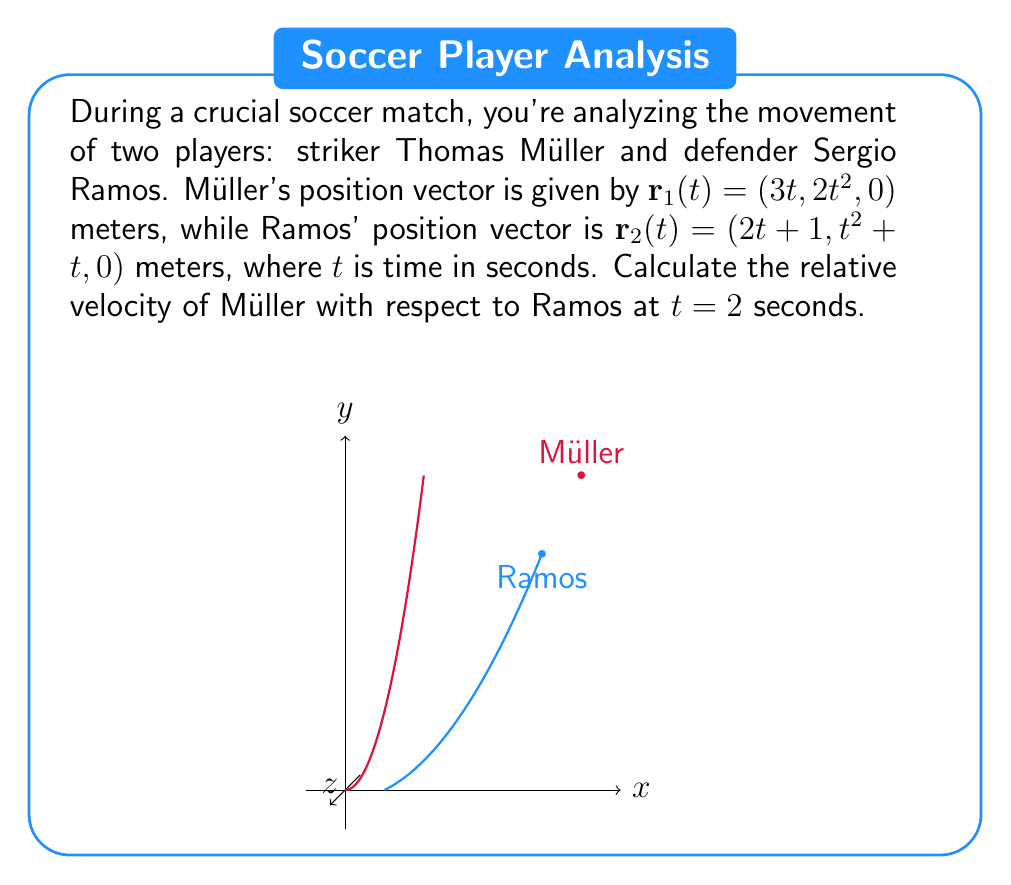Provide a solution to this math problem. To solve this problem, we'll follow these steps:

1) First, we need to find the velocity vectors for both players by differentiating their position vectors with respect to time:

   For Müller: $\mathbf{v}_1(t) = \frac{d}{dt}\mathbf{r}_1(t) = (3, 4t, 0)$
   For Ramos: $\mathbf{v}_2(t) = \frac{d}{dt}\mathbf{r}_2(t) = (2, 2t+1, 0)$

2) The relative velocity is the difference between these velocity vectors:

   $\mathbf{v}_{rel}(t) = \mathbf{v}_1(t) - \mathbf{v}_2(t) = (3, 4t, 0) - (2, 2t+1, 0) = (1, 2t-1, 0)$

3) Now, we evaluate this at $t=2$ seconds:

   $\mathbf{v}_{rel}(2) = (1, 2(2)-1, 0) = (1, 3, 0)$

4) To get the magnitude of this relative velocity, we calculate:

   $\|\mathbf{v}_{rel}(2)\| = \sqrt{1^2 + 3^2 + 0^2} = \sqrt{10}$ meters/second

Therefore, at $t=2$ seconds, Müller's velocity relative to Ramos is $(1, 3, 0)$ meters/second, with a magnitude of $\sqrt{10}$ meters/second.
Answer: $(1, 3, 0)$ m/s, magnitude $\sqrt{10}$ m/s 